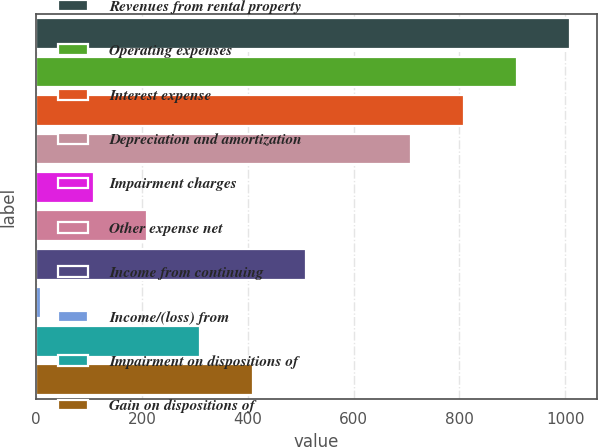<chart> <loc_0><loc_0><loc_500><loc_500><bar_chart><fcel>Revenues from rental property<fcel>Operating expenses<fcel>Interest expense<fcel>Depreciation and amortization<fcel>Impairment charges<fcel>Other expense net<fcel>Income from continuing<fcel>Income/(loss) from<fcel>Impairment on dispositions of<fcel>Gain on dispositions of<nl><fcel>1009.2<fcel>909.19<fcel>809.18<fcel>709.17<fcel>109.11<fcel>209.12<fcel>509.15<fcel>9.1<fcel>309.13<fcel>409.14<nl></chart> 